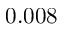<formula> <loc_0><loc_0><loc_500><loc_500>0 . 0 0 8</formula> 